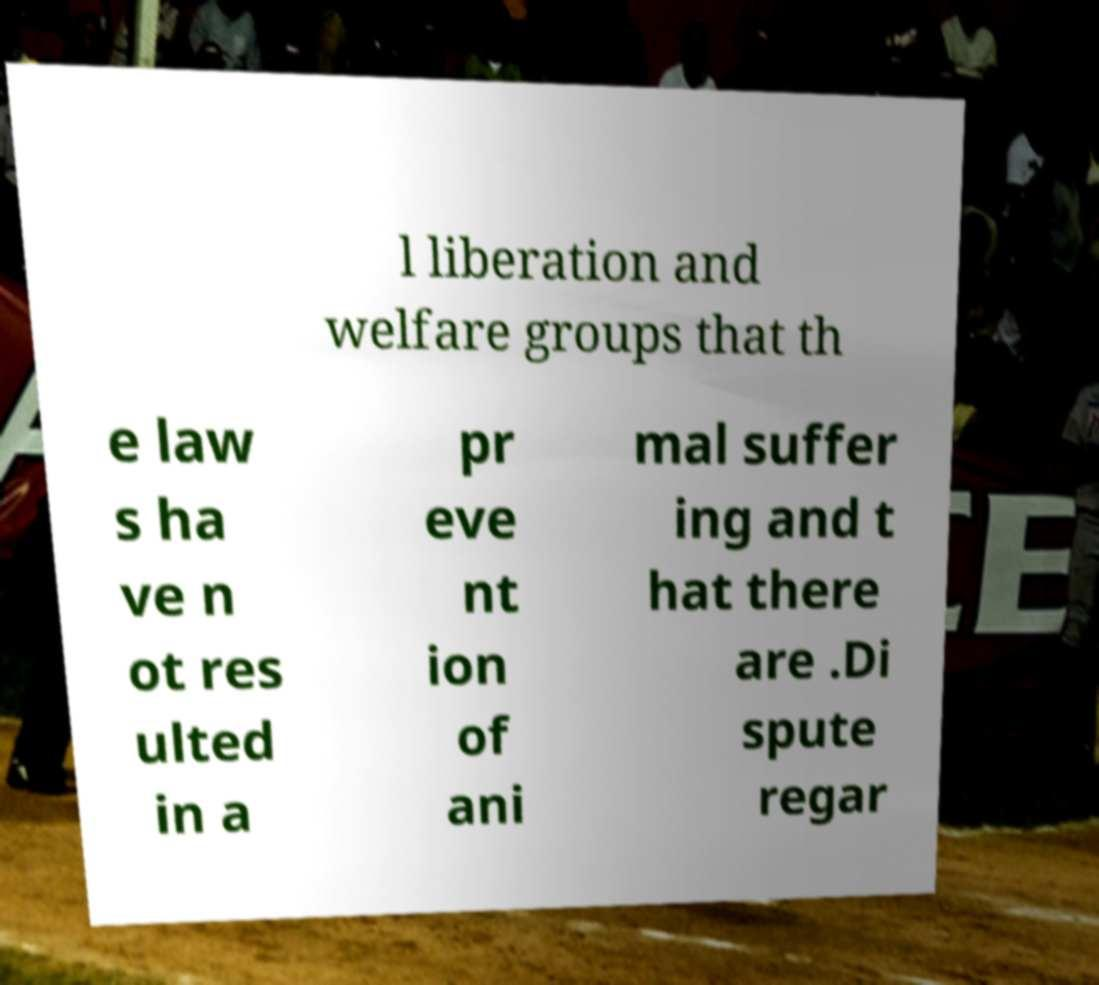Please identify and transcribe the text found in this image. l liberation and welfare groups that th e law s ha ve n ot res ulted in a pr eve nt ion of ani mal suffer ing and t hat there are .Di spute regar 